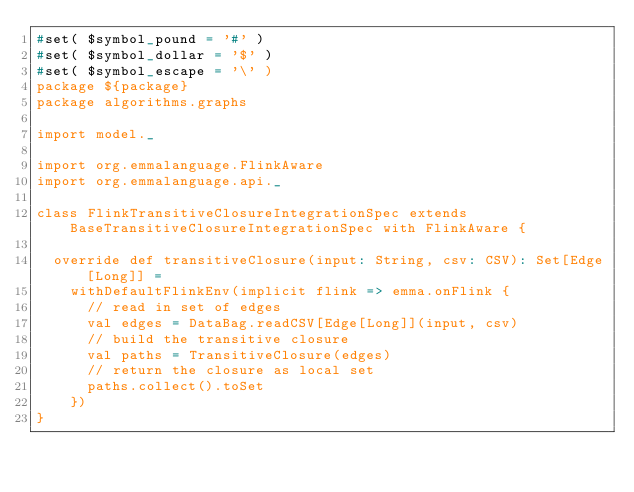Convert code to text. <code><loc_0><loc_0><loc_500><loc_500><_Scala_>#set( $symbol_pound = '#' )
#set( $symbol_dollar = '$' )
#set( $symbol_escape = '\' )
package ${package}
package algorithms.graphs

import model._

import org.emmalanguage.FlinkAware
import org.emmalanguage.api._

class FlinkTransitiveClosureIntegrationSpec extends BaseTransitiveClosureIntegrationSpec with FlinkAware {

  override def transitiveClosure(input: String, csv: CSV): Set[Edge[Long]] =
    withDefaultFlinkEnv(implicit flink => emma.onFlink {
      // read in set of edges
      val edges = DataBag.readCSV[Edge[Long]](input, csv)
      // build the transitive closure
      val paths = TransitiveClosure(edges)
      // return the closure as local set
      paths.collect().toSet
    })
}
</code> 